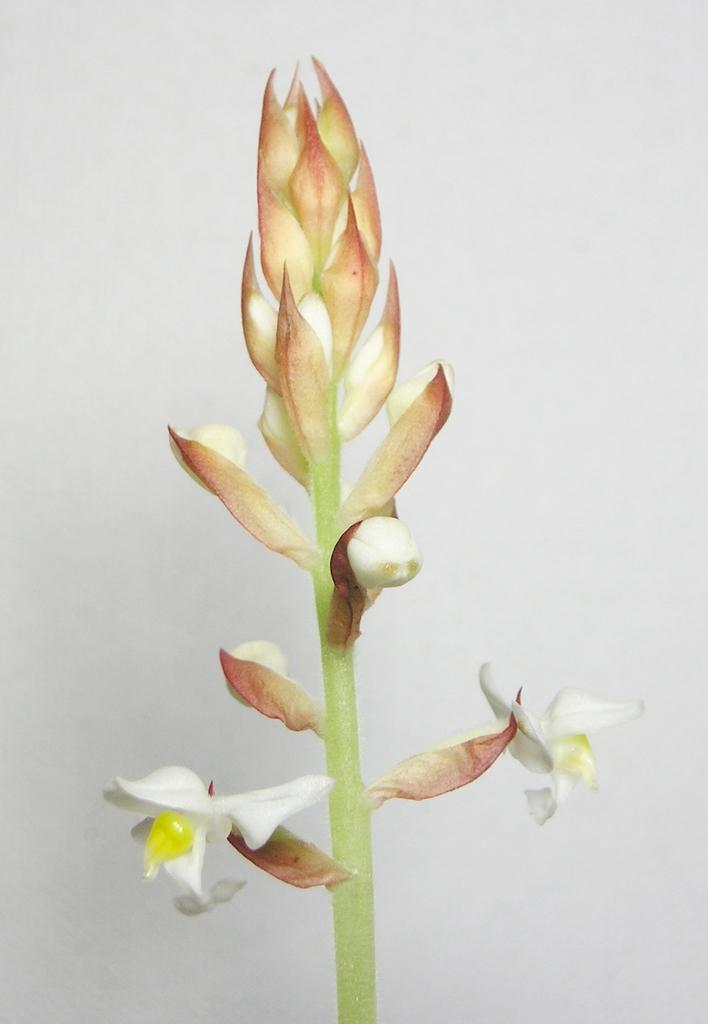What is the main subject of the image? There is a flower in the image. What can be seen behind the flower? There is a wall behind the flower in the image. What is the condition of the dust on the flower in the image? There is no dust mentioned or visible on the flower in the image. 